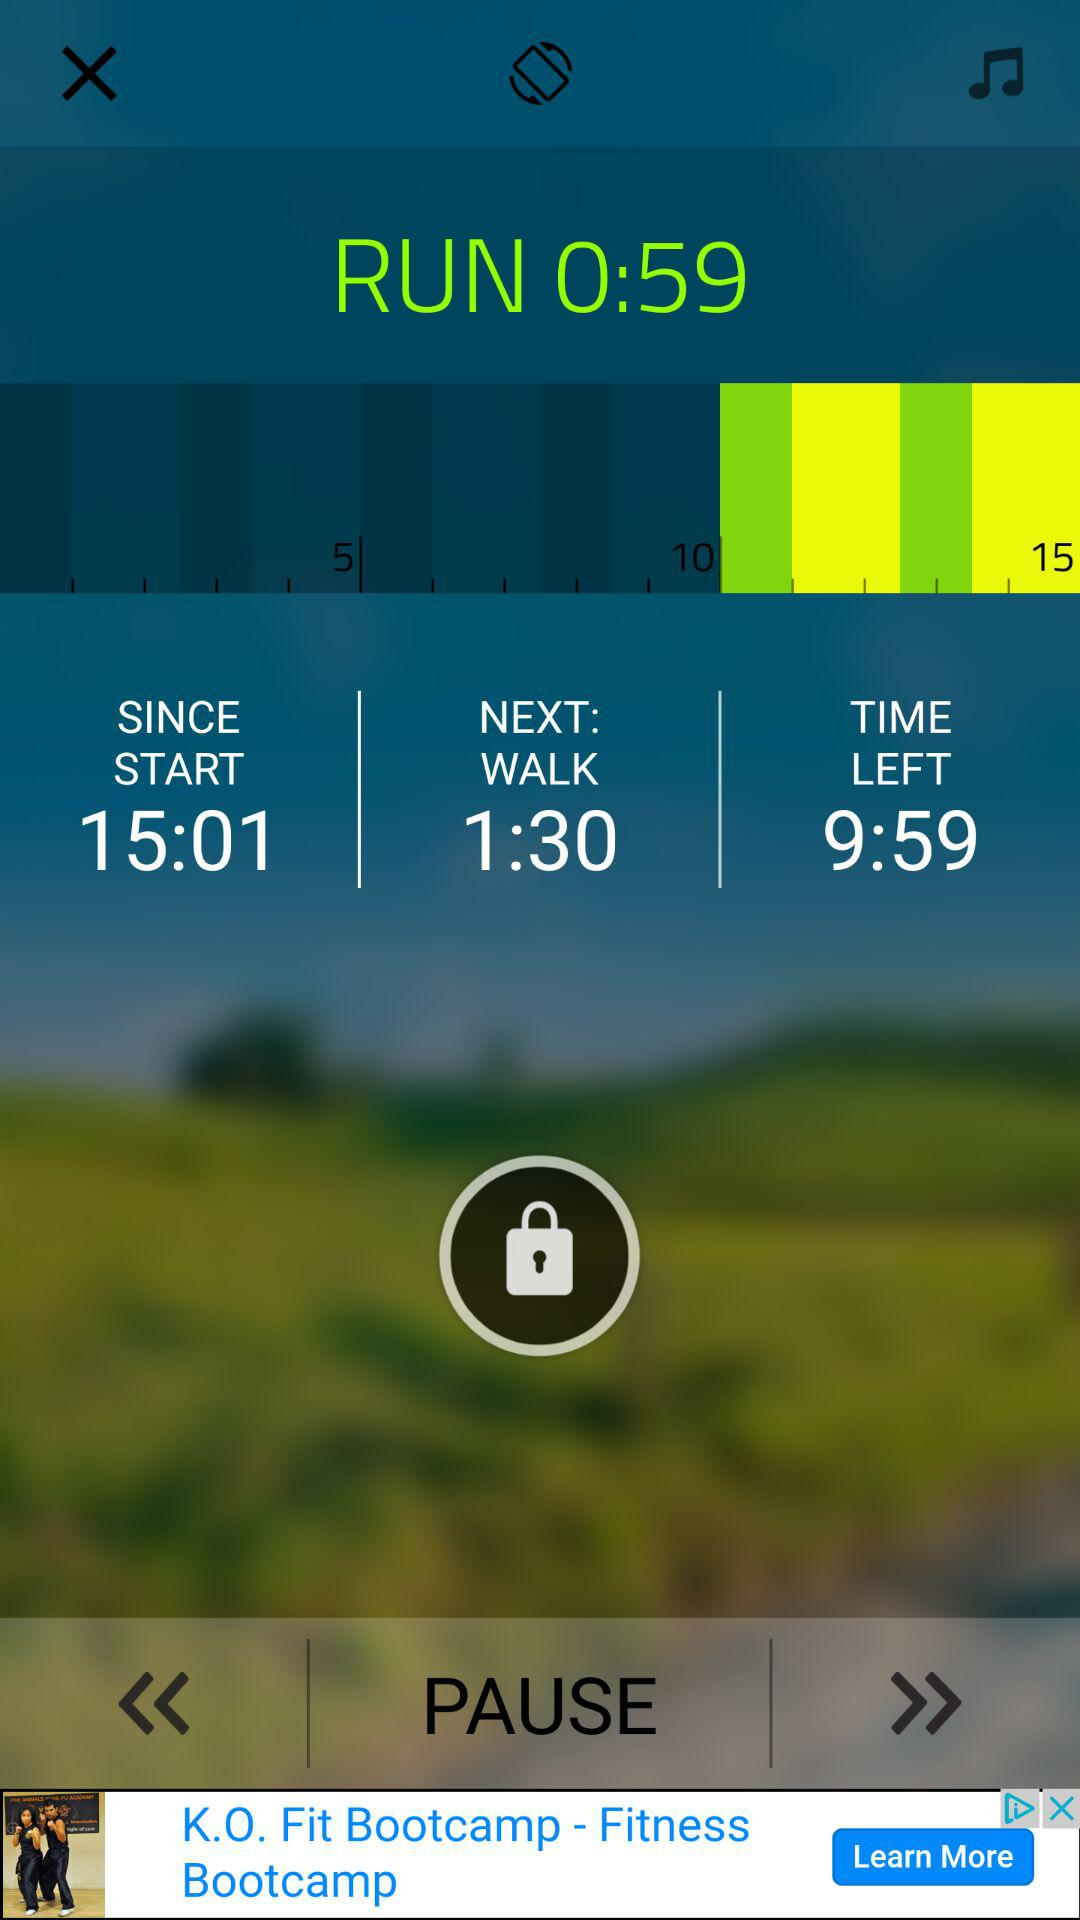What is the total time left? The total time left is 9 minutes 59 seconds. 